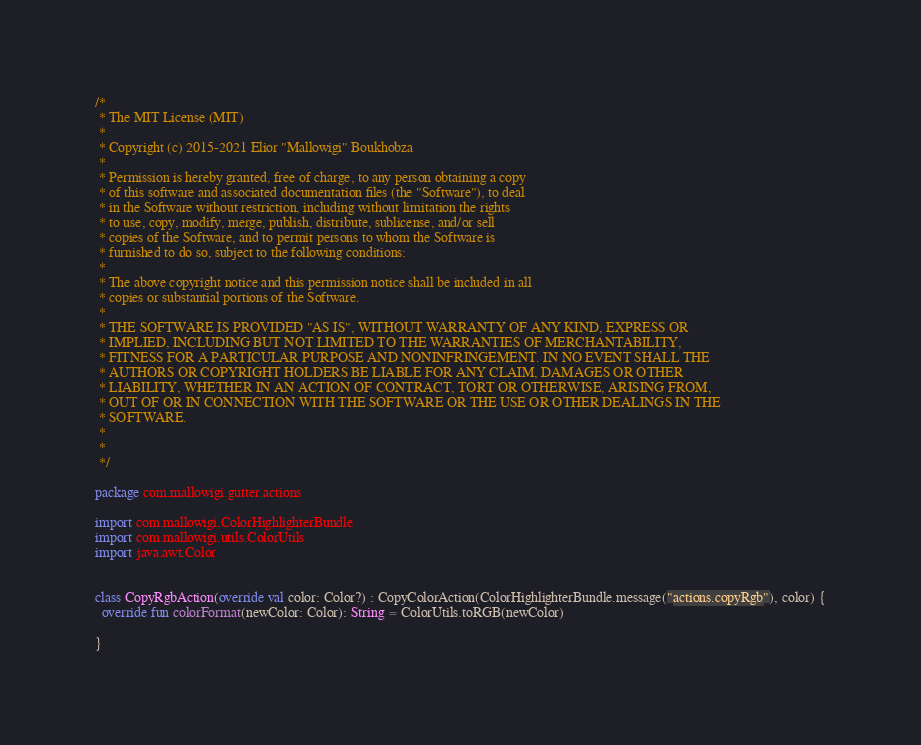<code> <loc_0><loc_0><loc_500><loc_500><_Kotlin_>/*
 * The MIT License (MIT)
 *
 * Copyright (c) 2015-2021 Elior "Mallowigi" Boukhobza
 *
 * Permission is hereby granted, free of charge, to any person obtaining a copy
 * of this software and associated documentation files (the "Software"), to deal
 * in the Software without restriction, including without limitation the rights
 * to use, copy, modify, merge, publish, distribute, sublicense, and/or sell
 * copies of the Software, and to permit persons to whom the Software is
 * furnished to do so, subject to the following conditions:
 *
 * The above copyright notice and this permission notice shall be included in all
 * copies or substantial portions of the Software.
 *
 * THE SOFTWARE IS PROVIDED "AS IS", WITHOUT WARRANTY OF ANY KIND, EXPRESS OR
 * IMPLIED, INCLUDING BUT NOT LIMITED TO THE WARRANTIES OF MERCHANTABILITY,
 * FITNESS FOR A PARTICULAR PURPOSE AND NONINFRINGEMENT. IN NO EVENT SHALL THE
 * AUTHORS OR COPYRIGHT HOLDERS BE LIABLE FOR ANY CLAIM, DAMAGES OR OTHER
 * LIABILITY, WHETHER IN AN ACTION OF CONTRACT, TORT OR OTHERWISE, ARISING FROM,
 * OUT OF OR IN CONNECTION WITH THE SOFTWARE OR THE USE OR OTHER DEALINGS IN THE
 * SOFTWARE.
 *
 *
 */

package com.mallowigi.gutter.actions

import com.mallowigi.ColorHighlighterBundle
import com.mallowigi.utils.ColorUtils
import java.awt.Color


class CopyRgbAction(override val color: Color?) : CopyColorAction(ColorHighlighterBundle.message("actions.copyRgb"), color) {
  override fun colorFormat(newColor: Color): String = ColorUtils.toRGB(newColor)

}
</code> 